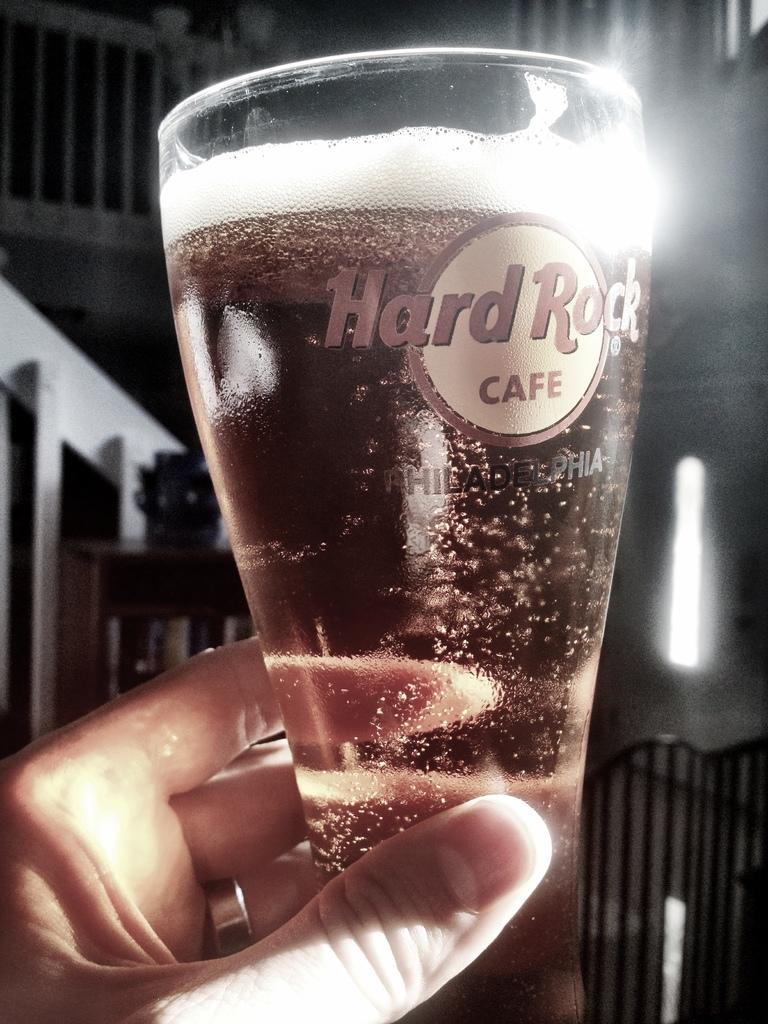<image>
Share a concise interpretation of the image provided. A glass with a bubble drink in it with the Hard Rock Cafe logo on the glass 